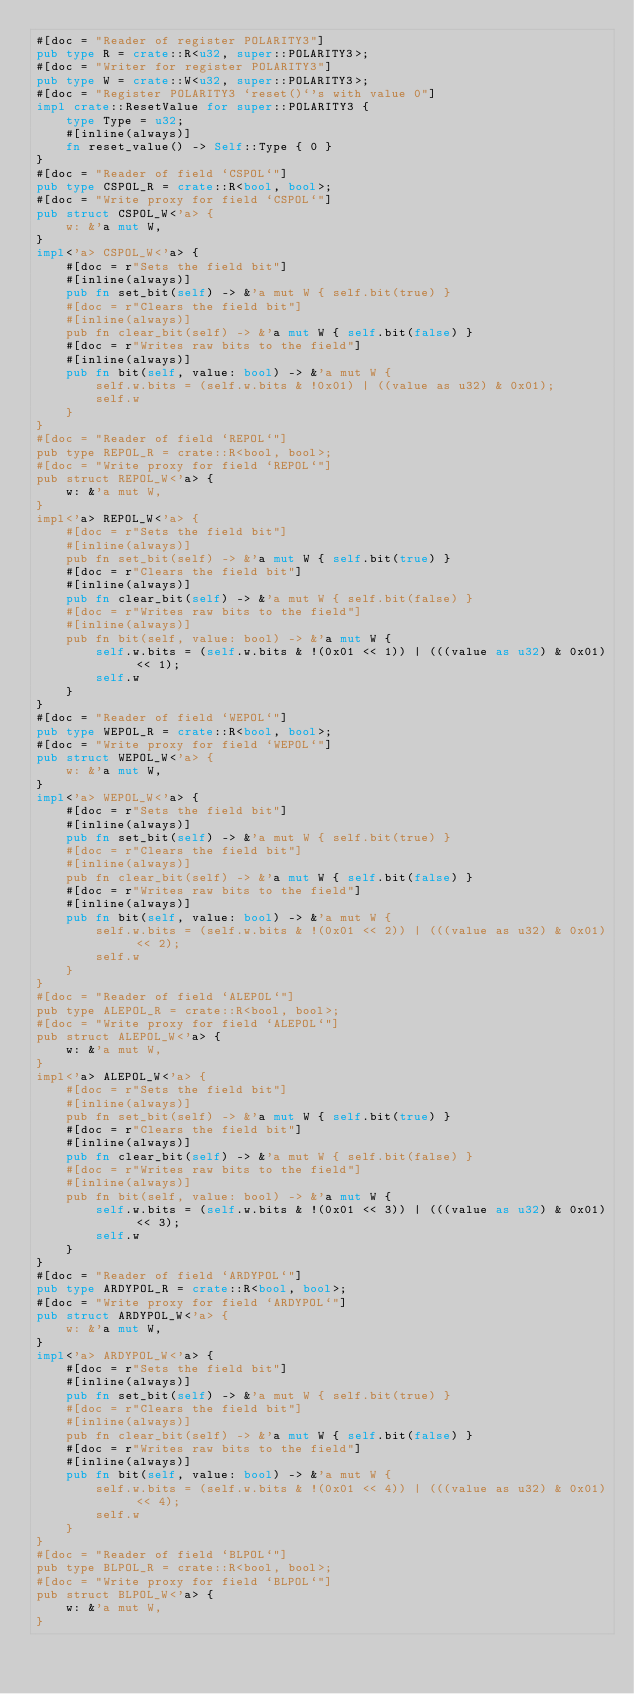<code> <loc_0><loc_0><loc_500><loc_500><_Rust_>#[doc = "Reader of register POLARITY3"]
pub type R = crate::R<u32, super::POLARITY3>;
#[doc = "Writer for register POLARITY3"]
pub type W = crate::W<u32, super::POLARITY3>;
#[doc = "Register POLARITY3 `reset()`'s with value 0"]
impl crate::ResetValue for super::POLARITY3 {
    type Type = u32;
    #[inline(always)]
    fn reset_value() -> Self::Type { 0 }
}
#[doc = "Reader of field `CSPOL`"]
pub type CSPOL_R = crate::R<bool, bool>;
#[doc = "Write proxy for field `CSPOL`"]
pub struct CSPOL_W<'a> {
    w: &'a mut W,
}
impl<'a> CSPOL_W<'a> {
    #[doc = r"Sets the field bit"]
    #[inline(always)]
    pub fn set_bit(self) -> &'a mut W { self.bit(true) }
    #[doc = r"Clears the field bit"]
    #[inline(always)]
    pub fn clear_bit(self) -> &'a mut W { self.bit(false) }
    #[doc = r"Writes raw bits to the field"]
    #[inline(always)]
    pub fn bit(self, value: bool) -> &'a mut W {
        self.w.bits = (self.w.bits & !0x01) | ((value as u32) & 0x01);
        self.w
    }
}
#[doc = "Reader of field `REPOL`"]
pub type REPOL_R = crate::R<bool, bool>;
#[doc = "Write proxy for field `REPOL`"]
pub struct REPOL_W<'a> {
    w: &'a mut W,
}
impl<'a> REPOL_W<'a> {
    #[doc = r"Sets the field bit"]
    #[inline(always)]
    pub fn set_bit(self) -> &'a mut W { self.bit(true) }
    #[doc = r"Clears the field bit"]
    #[inline(always)]
    pub fn clear_bit(self) -> &'a mut W { self.bit(false) }
    #[doc = r"Writes raw bits to the field"]
    #[inline(always)]
    pub fn bit(self, value: bool) -> &'a mut W {
        self.w.bits = (self.w.bits & !(0x01 << 1)) | (((value as u32) & 0x01) << 1);
        self.w
    }
}
#[doc = "Reader of field `WEPOL`"]
pub type WEPOL_R = crate::R<bool, bool>;
#[doc = "Write proxy for field `WEPOL`"]
pub struct WEPOL_W<'a> {
    w: &'a mut W,
}
impl<'a> WEPOL_W<'a> {
    #[doc = r"Sets the field bit"]
    #[inline(always)]
    pub fn set_bit(self) -> &'a mut W { self.bit(true) }
    #[doc = r"Clears the field bit"]
    #[inline(always)]
    pub fn clear_bit(self) -> &'a mut W { self.bit(false) }
    #[doc = r"Writes raw bits to the field"]
    #[inline(always)]
    pub fn bit(self, value: bool) -> &'a mut W {
        self.w.bits = (self.w.bits & !(0x01 << 2)) | (((value as u32) & 0x01) << 2);
        self.w
    }
}
#[doc = "Reader of field `ALEPOL`"]
pub type ALEPOL_R = crate::R<bool, bool>;
#[doc = "Write proxy for field `ALEPOL`"]
pub struct ALEPOL_W<'a> {
    w: &'a mut W,
}
impl<'a> ALEPOL_W<'a> {
    #[doc = r"Sets the field bit"]
    #[inline(always)]
    pub fn set_bit(self) -> &'a mut W { self.bit(true) }
    #[doc = r"Clears the field bit"]
    #[inline(always)]
    pub fn clear_bit(self) -> &'a mut W { self.bit(false) }
    #[doc = r"Writes raw bits to the field"]
    #[inline(always)]
    pub fn bit(self, value: bool) -> &'a mut W {
        self.w.bits = (self.w.bits & !(0x01 << 3)) | (((value as u32) & 0x01) << 3);
        self.w
    }
}
#[doc = "Reader of field `ARDYPOL`"]
pub type ARDYPOL_R = crate::R<bool, bool>;
#[doc = "Write proxy for field `ARDYPOL`"]
pub struct ARDYPOL_W<'a> {
    w: &'a mut W,
}
impl<'a> ARDYPOL_W<'a> {
    #[doc = r"Sets the field bit"]
    #[inline(always)]
    pub fn set_bit(self) -> &'a mut W { self.bit(true) }
    #[doc = r"Clears the field bit"]
    #[inline(always)]
    pub fn clear_bit(self) -> &'a mut W { self.bit(false) }
    #[doc = r"Writes raw bits to the field"]
    #[inline(always)]
    pub fn bit(self, value: bool) -> &'a mut W {
        self.w.bits = (self.w.bits & !(0x01 << 4)) | (((value as u32) & 0x01) << 4);
        self.w
    }
}
#[doc = "Reader of field `BLPOL`"]
pub type BLPOL_R = crate::R<bool, bool>;
#[doc = "Write proxy for field `BLPOL`"]
pub struct BLPOL_W<'a> {
    w: &'a mut W,
}</code> 